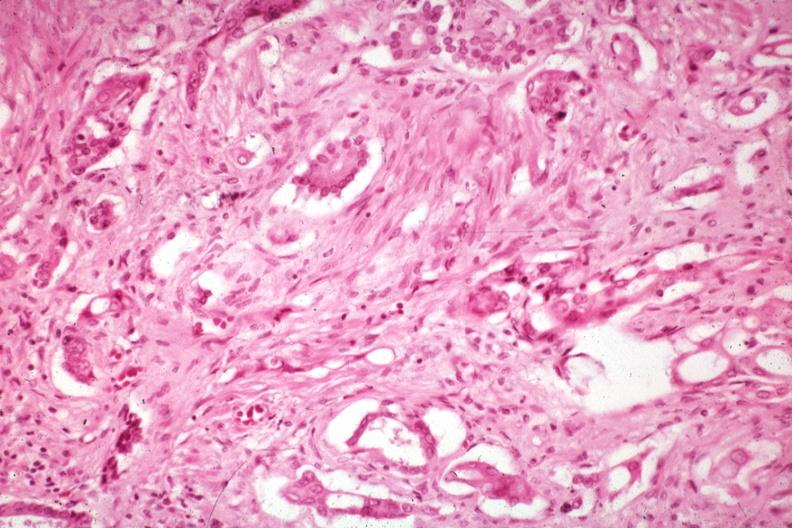where is this?
Answer the question using a single word or phrase. Pancreas 